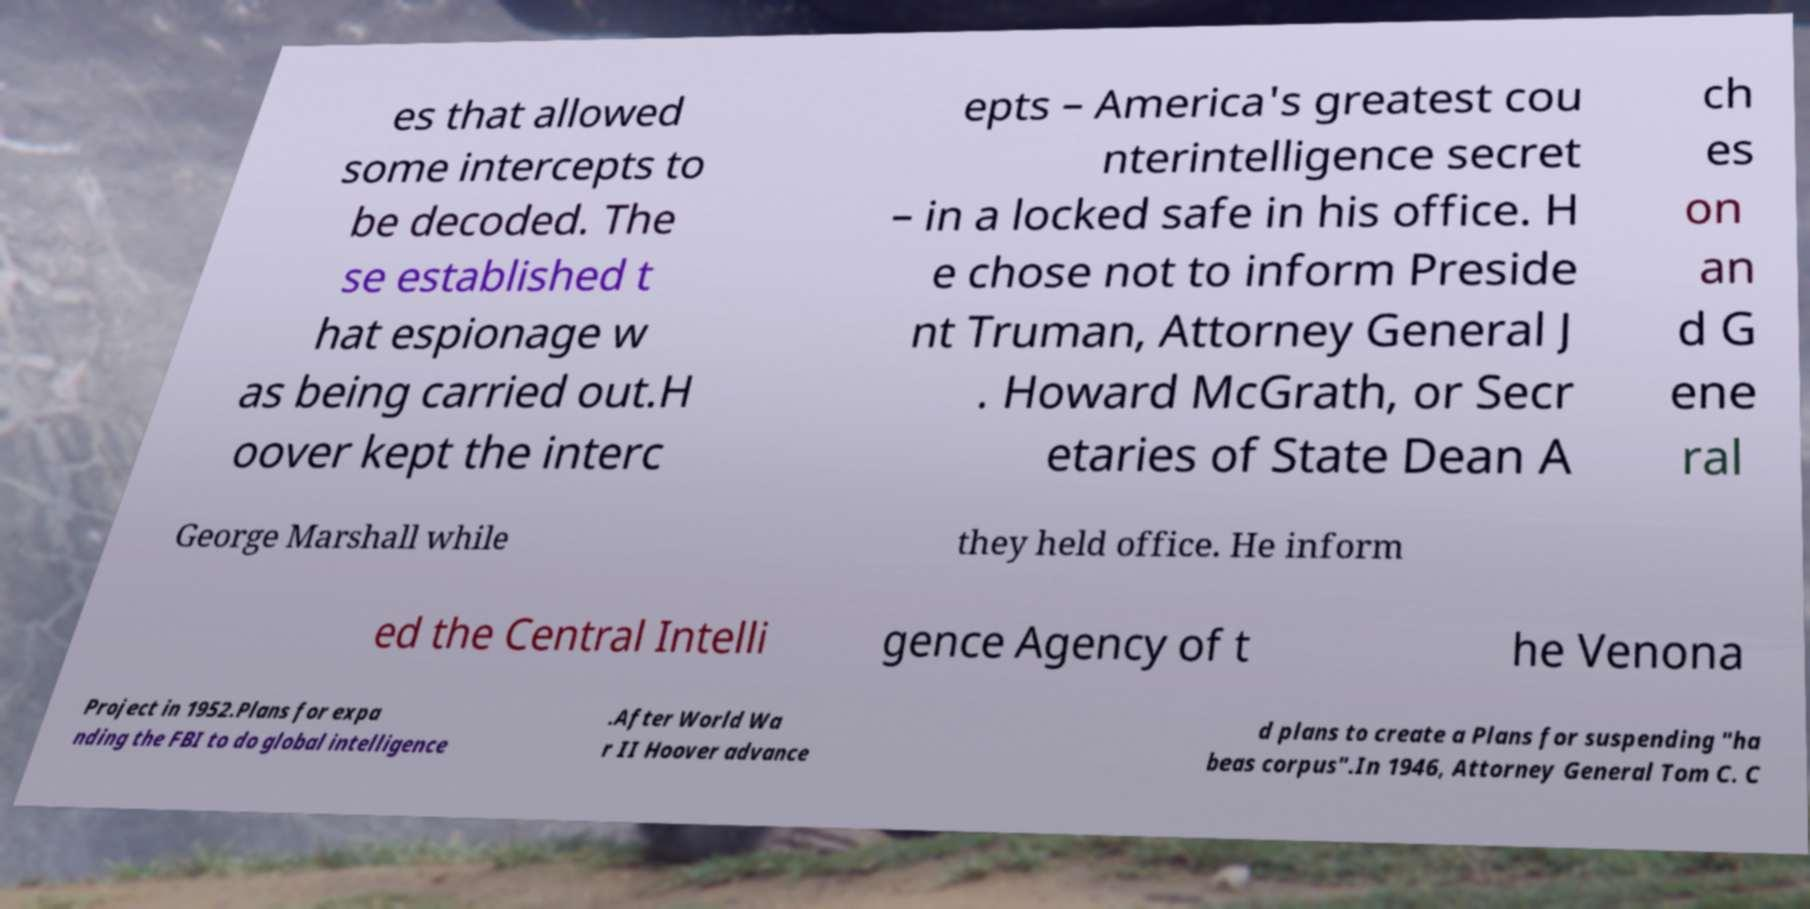For documentation purposes, I need the text within this image transcribed. Could you provide that? es that allowed some intercepts to be decoded. The se established t hat espionage w as being carried out.H oover kept the interc epts – America's greatest cou nterintelligence secret – in a locked safe in his office. H e chose not to inform Preside nt Truman, Attorney General J . Howard McGrath, or Secr etaries of State Dean A ch es on an d G ene ral George Marshall while they held office. He inform ed the Central Intelli gence Agency of t he Venona Project in 1952.Plans for expa nding the FBI to do global intelligence .After World Wa r II Hoover advance d plans to create a Plans for suspending "ha beas corpus".In 1946, Attorney General Tom C. C 